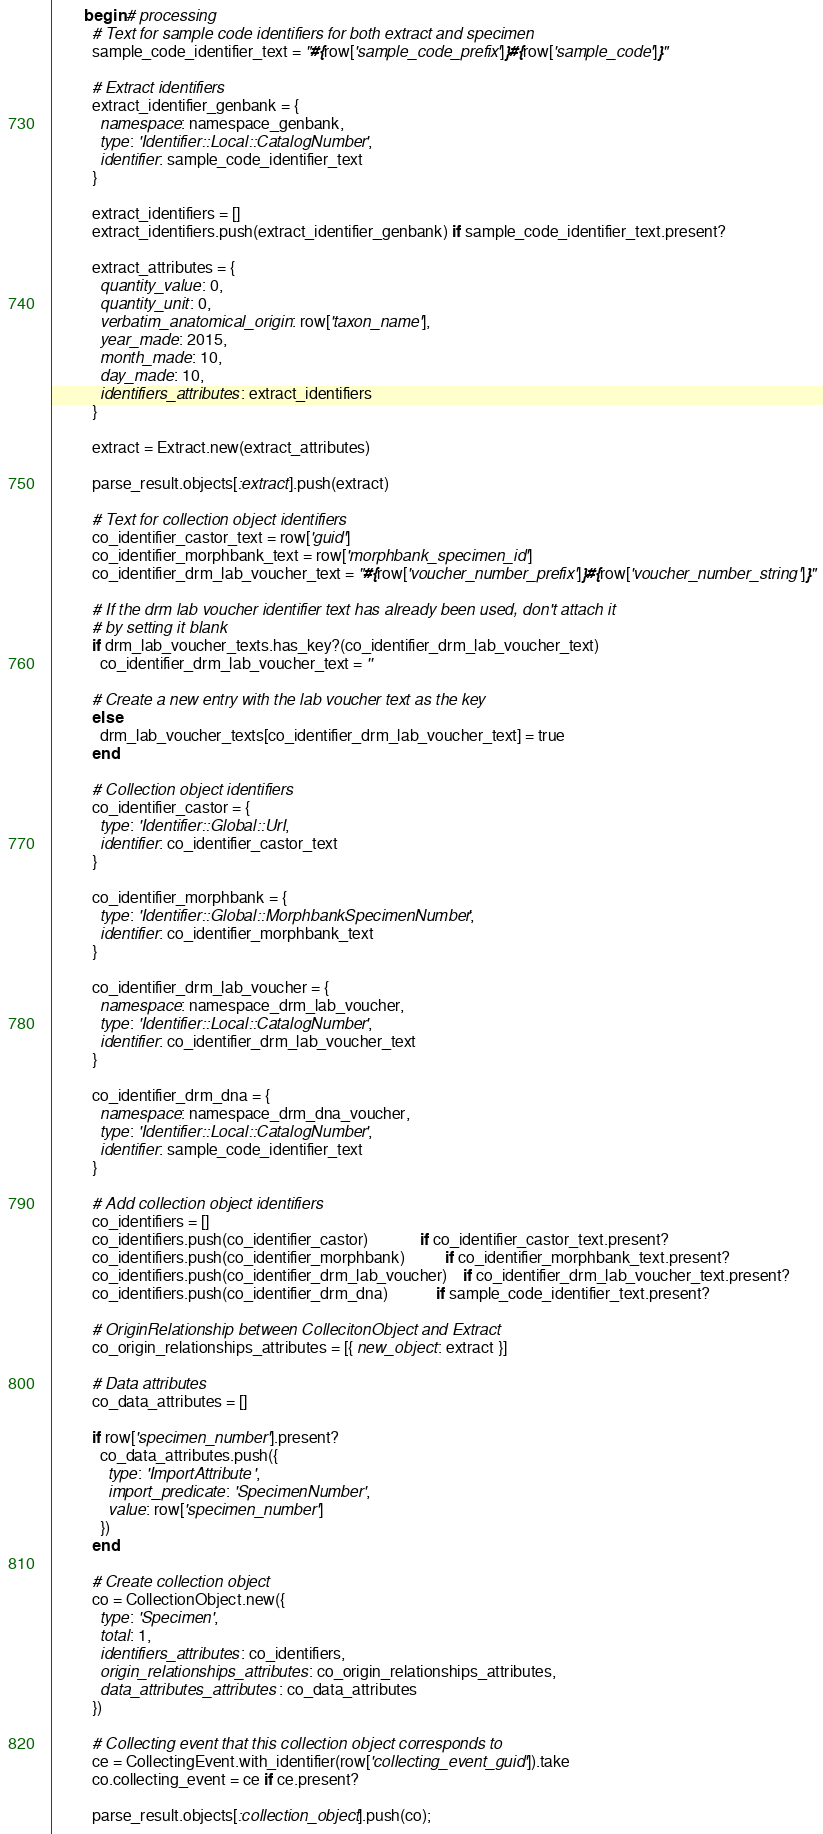<code> <loc_0><loc_0><loc_500><loc_500><_Ruby_>        begin # processing
          # Text for sample code identifiers for both extract and specimen
          sample_code_identifier_text = "#{row['sample_code_prefix']}#{row['sample_code']}"

          # Extract identifiers
          extract_identifier_genbank = {
            namespace: namespace_genbank,
            type: 'Identifier::Local::CatalogNumber',
            identifier: sample_code_identifier_text
          }

          extract_identifiers = []
          extract_identifiers.push(extract_identifier_genbank) if sample_code_identifier_text.present?

          extract_attributes = {
            quantity_value: 0,
            quantity_unit: 0,
            verbatim_anatomical_origin: row['taxon_name'],
            year_made: 2015,
            month_made: 10,
            day_made: 10,
            identifiers_attributes: extract_identifiers
          }

          extract = Extract.new(extract_attributes)

          parse_result.objects[:extract].push(extract)

          # Text for collection object identifiers
          co_identifier_castor_text = row['guid']
          co_identifier_morphbank_text = row['morphbank_specimen_id']
          co_identifier_drm_lab_voucher_text = "#{row['voucher_number_prefix']}#{row['voucher_number_string']}"

          # If the drm lab voucher identifier text has already been used, don't attach it
          # by setting it blank
          if drm_lab_voucher_texts.has_key?(co_identifier_drm_lab_voucher_text)
            co_identifier_drm_lab_voucher_text = ''

          # Create a new entry with the lab voucher text as the key
          else
            drm_lab_voucher_texts[co_identifier_drm_lab_voucher_text] = true
          end

          # Collection object identifiers
          co_identifier_castor = {
            type: 'Identifier::Global::Uri',
            identifier: co_identifier_castor_text
          }

          co_identifier_morphbank = {
            type: 'Identifier::Global::MorphbankSpecimenNumber',
            identifier: co_identifier_morphbank_text
          }

          co_identifier_drm_lab_voucher = {
            namespace: namespace_drm_lab_voucher,
            type: 'Identifier::Local::CatalogNumber',
            identifier: co_identifier_drm_lab_voucher_text
          }

          co_identifier_drm_dna = {
            namespace: namespace_drm_dna_voucher,
            type: 'Identifier::Local::CatalogNumber',
            identifier: sample_code_identifier_text
          }

          # Add collection object identifiers
          co_identifiers = []
          co_identifiers.push(co_identifier_castor)             if co_identifier_castor_text.present?
          co_identifiers.push(co_identifier_morphbank)          if co_identifier_morphbank_text.present?
          co_identifiers.push(co_identifier_drm_lab_voucher)    if co_identifier_drm_lab_voucher_text.present?
          co_identifiers.push(co_identifier_drm_dna)            if sample_code_identifier_text.present?

          # OriginRelationship between CollecitonObject and Extract
          co_origin_relationships_attributes = [{ new_object: extract }]

          # Data attributes
          co_data_attributes = []

          if row['specimen_number'].present?
            co_data_attributes.push({
              type: 'ImportAttribute',
              import_predicate: 'SpecimenNumber',
              value: row['specimen_number']
            })
          end

          # Create collection object
          co = CollectionObject.new({
            type: 'Specimen',
            total: 1,
            identifiers_attributes: co_identifiers,
            origin_relationships_attributes: co_origin_relationships_attributes,
            data_attributes_attributes: co_data_attributes
          })

          # Collecting event that this collection object corresponds to
          ce = CollectingEvent.with_identifier(row['collecting_event_guid']).take
          co.collecting_event = ce if ce.present?

          parse_result.objects[:collection_object].push(co);</code> 